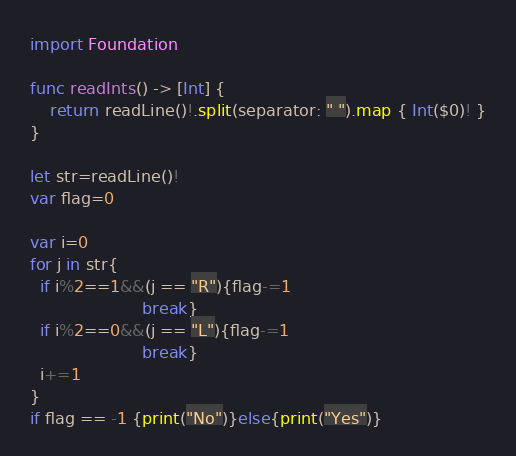Convert code to text. <code><loc_0><loc_0><loc_500><loc_500><_Swift_>import Foundation

func readInts() -> [Int] {
    return readLine()!.split(separator: " ").map { Int($0)! }
}

let str=readLine()!
var flag=0

var i=0
for j in str{
  if i%2==1&&(j == "R"){flag-=1
                      break}
  if i%2==0&&(j == "L"){flag-=1
                      break}
  i+=1
}
if flag == -1 {print("No")}else{print("Yes")}</code> 